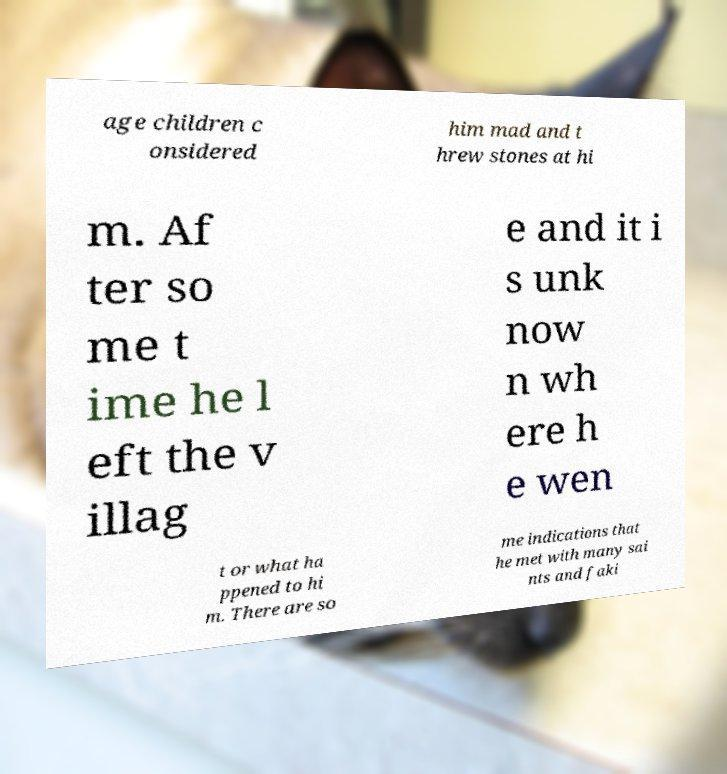Could you assist in decoding the text presented in this image and type it out clearly? age children c onsidered him mad and t hrew stones at hi m. Af ter so me t ime he l eft the v illag e and it i s unk now n wh ere h e wen t or what ha ppened to hi m. There are so me indications that he met with many sai nts and faki 